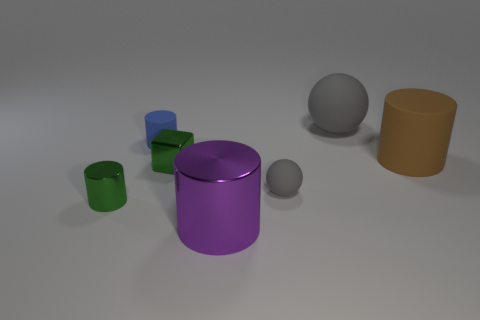Subtract all small blue matte cylinders. How many cylinders are left? 3 Add 1 small gray spheres. How many objects exist? 8 Subtract all green cylinders. How many cylinders are left? 3 Subtract all purple cylinders. Subtract all yellow cubes. How many cylinders are left? 3 Subtract 1 brown cylinders. How many objects are left? 6 Subtract all cylinders. How many objects are left? 3 Subtract all small green cylinders. Subtract all big gray things. How many objects are left? 5 Add 2 large metallic cylinders. How many large metallic cylinders are left? 3 Add 2 brown things. How many brown things exist? 3 